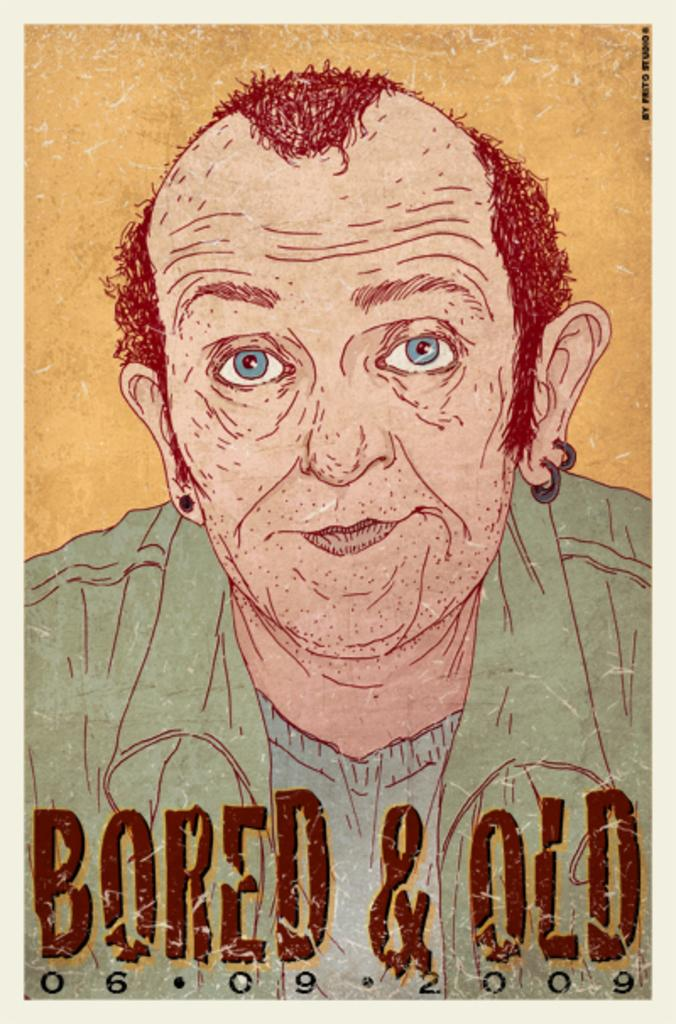<image>
Describe the image concisely. a cartoon photo that says bored and old 